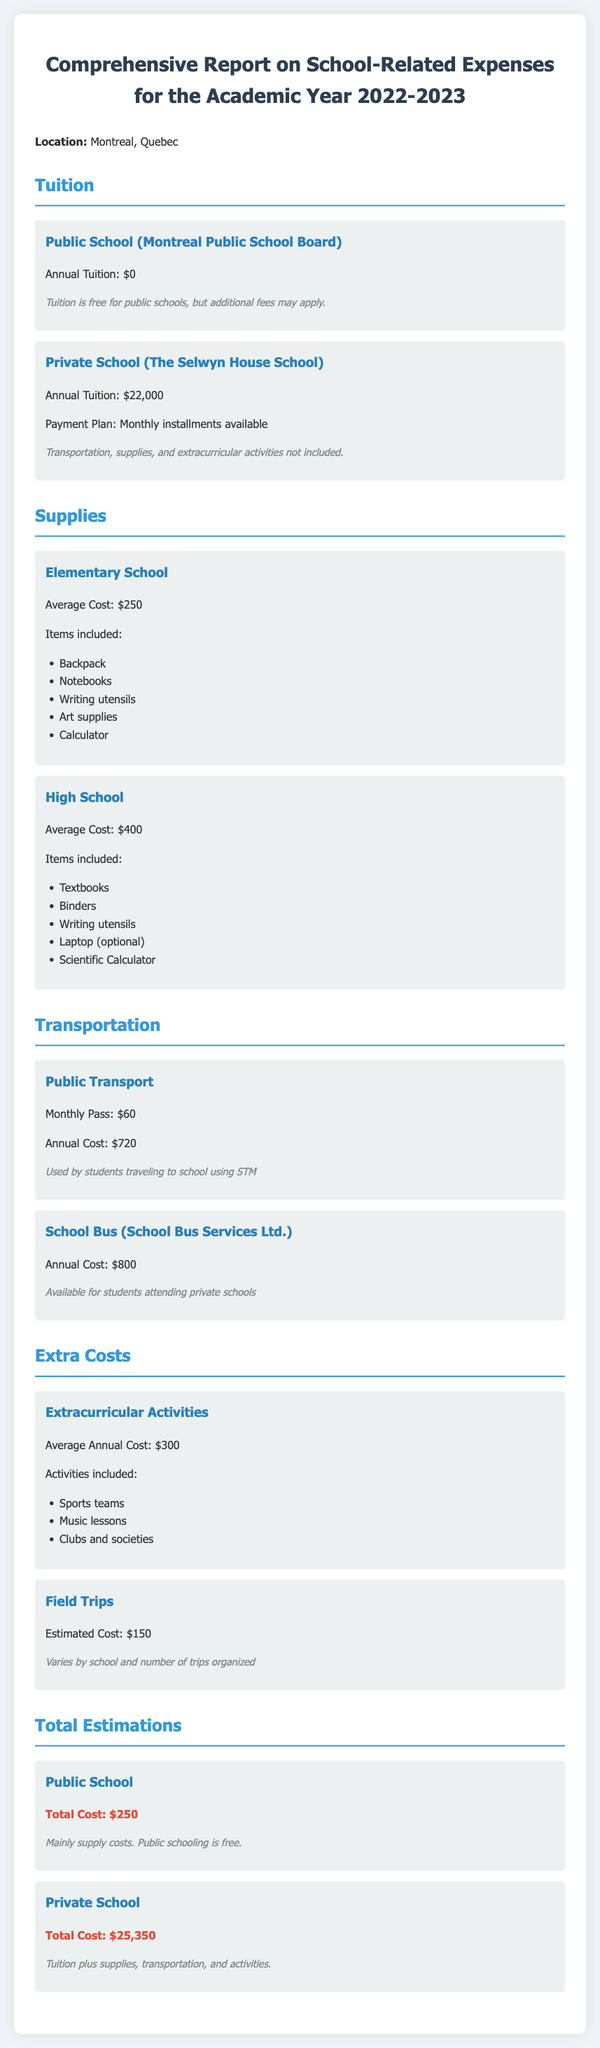What is the annual tuition for public school? The annual tuition for public school is stated as $0 because it is free.
Answer: $0 What is the average cost of supplies for elementary school? The average cost of supplies for elementary school is listed as $250.
Answer: $250 What is the total cost for private school expenses? The total cost for private school includes tuition, supplies, transportation, and activities, which sums up to $25,350.
Answer: $25,350 How much does a monthly public transport pass cost? The document specifies that a monthly public transport pass costs $60.
Answer: $60 What items are included in the high school supplies? The listed items for high school supplies include textbooks, binders, writing utensils, laptop (optional), and scientific calculator.
Answer: Textbooks, binders, writing utensils, laptop (optional), scientific calculator What is the annual cost for school bus services? The school bus services for private school students is stated to have an annual cost of $800.
Answer: $800 What is the estimated cost for field trips? The estimated cost for field trips is shown as $150.
Answer: $150 What is the note regarding tuition for private school? The note clarifies that transportation, supplies, and extracurricular activities are not included in the tuition for private school.
Answer: Not included What is the average annual cost for extracurricular activities? The average annual cost for extracurricular activities is listed as $300.
Answer: $300 